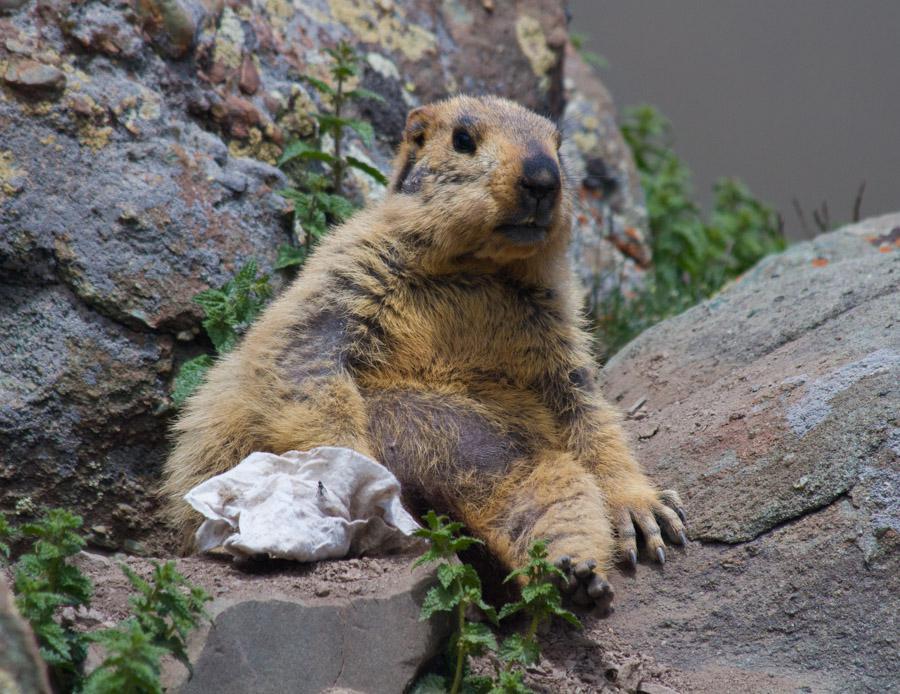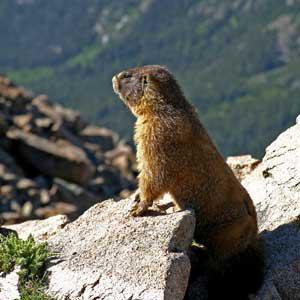The first image is the image on the left, the second image is the image on the right. Considering the images on both sides, is "The animal in the image on the left is facing left." valid? Answer yes or no. No. 